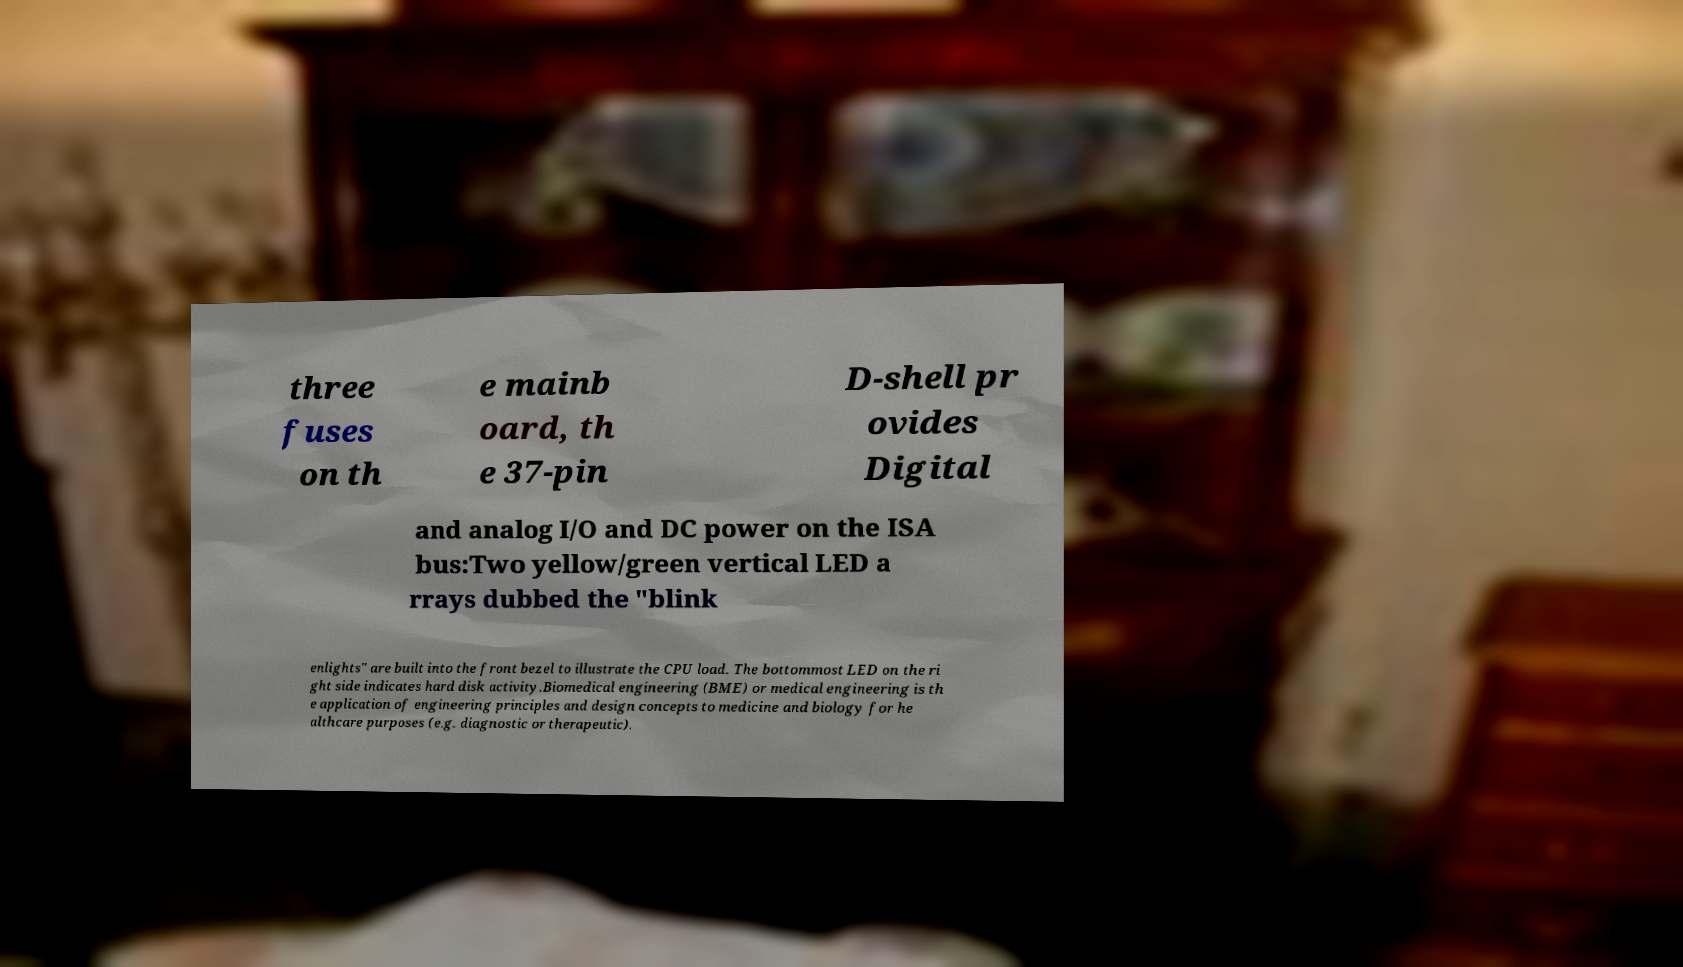Could you assist in decoding the text presented in this image and type it out clearly? three fuses on th e mainb oard, th e 37-pin D-shell pr ovides Digital and analog I/O and DC power on the ISA bus:Two yellow/green vertical LED a rrays dubbed the "blink enlights" are built into the front bezel to illustrate the CPU load. The bottommost LED on the ri ght side indicates hard disk activity.Biomedical engineering (BME) or medical engineering is th e application of engineering principles and design concepts to medicine and biology for he althcare purposes (e.g. diagnostic or therapeutic). 